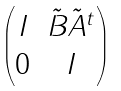<formula> <loc_0><loc_0><loc_500><loc_500>\begin{pmatrix} I & \tilde { B } \tilde { A } ^ { t } \\ 0 & I \end{pmatrix}</formula> 